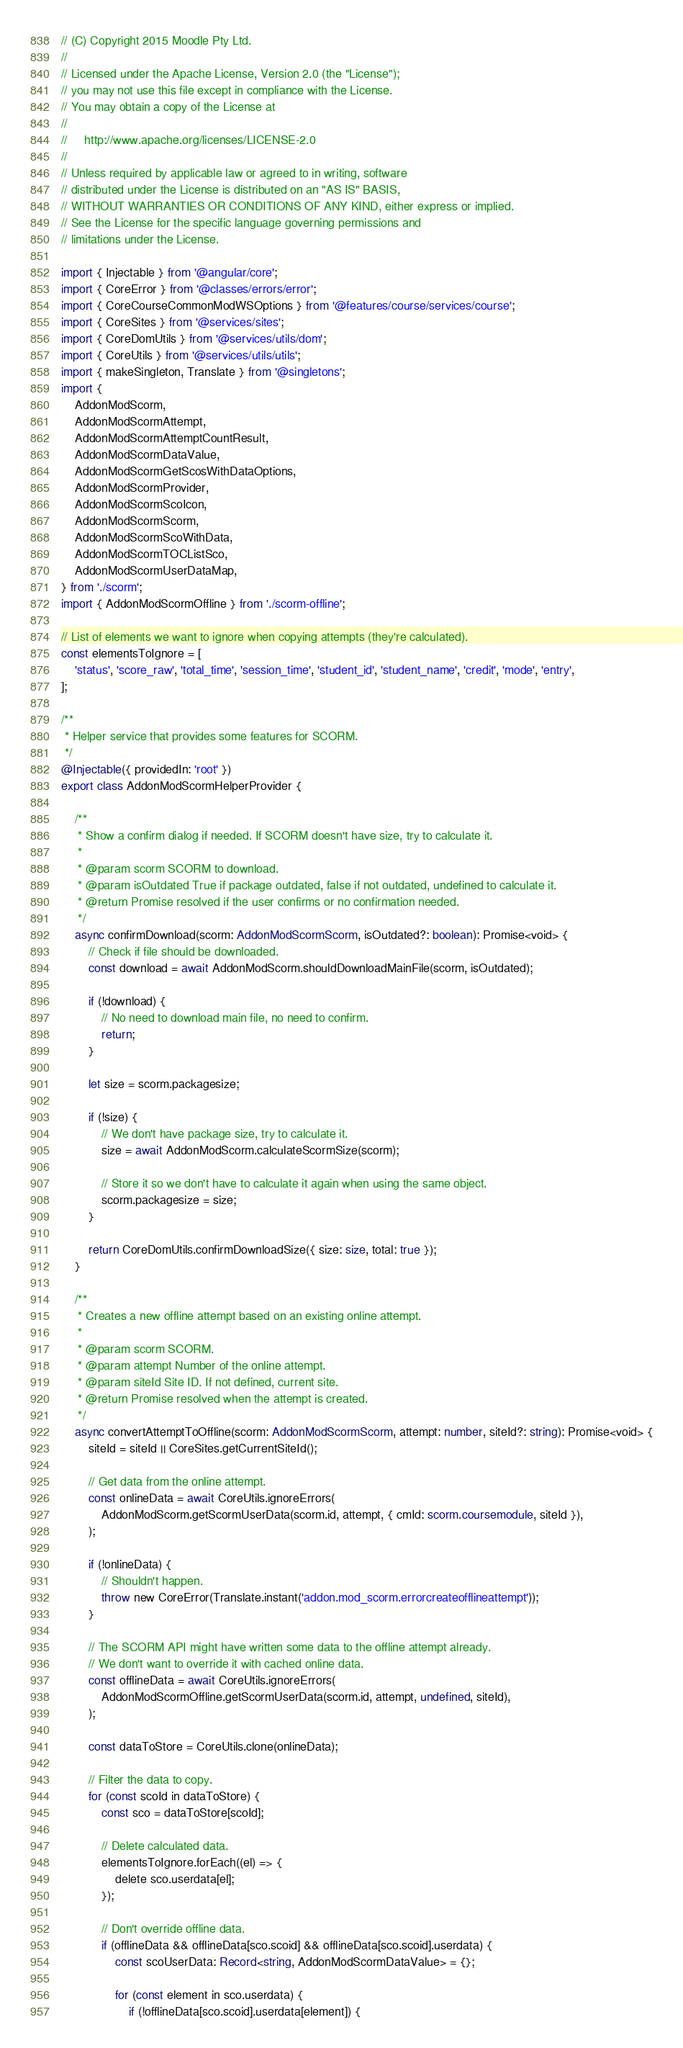Convert code to text. <code><loc_0><loc_0><loc_500><loc_500><_TypeScript_>// (C) Copyright 2015 Moodle Pty Ltd.
//
// Licensed under the Apache License, Version 2.0 (the "License");
// you may not use this file except in compliance with the License.
// You may obtain a copy of the License at
//
//     http://www.apache.org/licenses/LICENSE-2.0
//
// Unless required by applicable law or agreed to in writing, software
// distributed under the License is distributed on an "AS IS" BASIS,
// WITHOUT WARRANTIES OR CONDITIONS OF ANY KIND, either express or implied.
// See the License for the specific language governing permissions and
// limitations under the License.

import { Injectable } from '@angular/core';
import { CoreError } from '@classes/errors/error';
import { CoreCourseCommonModWSOptions } from '@features/course/services/course';
import { CoreSites } from '@services/sites';
import { CoreDomUtils } from '@services/utils/dom';
import { CoreUtils } from '@services/utils/utils';
import { makeSingleton, Translate } from '@singletons';
import {
    AddonModScorm,
    AddonModScormAttempt,
    AddonModScormAttemptCountResult,
    AddonModScormDataValue,
    AddonModScormGetScosWithDataOptions,
    AddonModScormProvider,
    AddonModScormScoIcon,
    AddonModScormScorm,
    AddonModScormScoWithData,
    AddonModScormTOCListSco,
    AddonModScormUserDataMap,
} from './scorm';
import { AddonModScormOffline } from './scorm-offline';

// List of elements we want to ignore when copying attempts (they're calculated).
const elementsToIgnore = [
    'status', 'score_raw', 'total_time', 'session_time', 'student_id', 'student_name', 'credit', 'mode', 'entry',
];

/**
 * Helper service that provides some features for SCORM.
 */
@Injectable({ providedIn: 'root' })
export class AddonModScormHelperProvider {

    /**
     * Show a confirm dialog if needed. If SCORM doesn't have size, try to calculate it.
     *
     * @param scorm SCORM to download.
     * @param isOutdated True if package outdated, false if not outdated, undefined to calculate it.
     * @return Promise resolved if the user confirms or no confirmation needed.
     */
    async confirmDownload(scorm: AddonModScormScorm, isOutdated?: boolean): Promise<void> {
        // Check if file should be downloaded.
        const download = await AddonModScorm.shouldDownloadMainFile(scorm, isOutdated);

        if (!download) {
            // No need to download main file, no need to confirm.
            return;
        }

        let size = scorm.packagesize;

        if (!size) {
            // We don't have package size, try to calculate it.
            size = await AddonModScorm.calculateScormSize(scorm);

            // Store it so we don't have to calculate it again when using the same object.
            scorm.packagesize = size;
        }

        return CoreDomUtils.confirmDownloadSize({ size: size, total: true });
    }

    /**
     * Creates a new offline attempt based on an existing online attempt.
     *
     * @param scorm SCORM.
     * @param attempt Number of the online attempt.
     * @param siteId Site ID. If not defined, current site.
     * @return Promise resolved when the attempt is created.
     */
    async convertAttemptToOffline(scorm: AddonModScormScorm, attempt: number, siteId?: string): Promise<void> {
        siteId = siteId || CoreSites.getCurrentSiteId();

        // Get data from the online attempt.
        const onlineData = await CoreUtils.ignoreErrors(
            AddonModScorm.getScormUserData(scorm.id, attempt, { cmId: scorm.coursemodule, siteId }),
        );

        if (!onlineData) {
            // Shouldn't happen.
            throw new CoreError(Translate.instant('addon.mod_scorm.errorcreateofflineattempt'));
        }

        // The SCORM API might have written some data to the offline attempt already.
        // We don't want to override it with cached online data.
        const offlineData = await CoreUtils.ignoreErrors(
            AddonModScormOffline.getScormUserData(scorm.id, attempt, undefined, siteId),
        );

        const dataToStore = CoreUtils.clone(onlineData);

        // Filter the data to copy.
        for (const scoId in dataToStore) {
            const sco = dataToStore[scoId];

            // Delete calculated data.
            elementsToIgnore.forEach((el) => {
                delete sco.userdata[el];
            });

            // Don't override offline data.
            if (offlineData && offlineData[sco.scoid] && offlineData[sco.scoid].userdata) {
                const scoUserData: Record<string, AddonModScormDataValue> = {};

                for (const element in sco.userdata) {
                    if (!offlineData[sco.scoid].userdata[element]) {</code> 